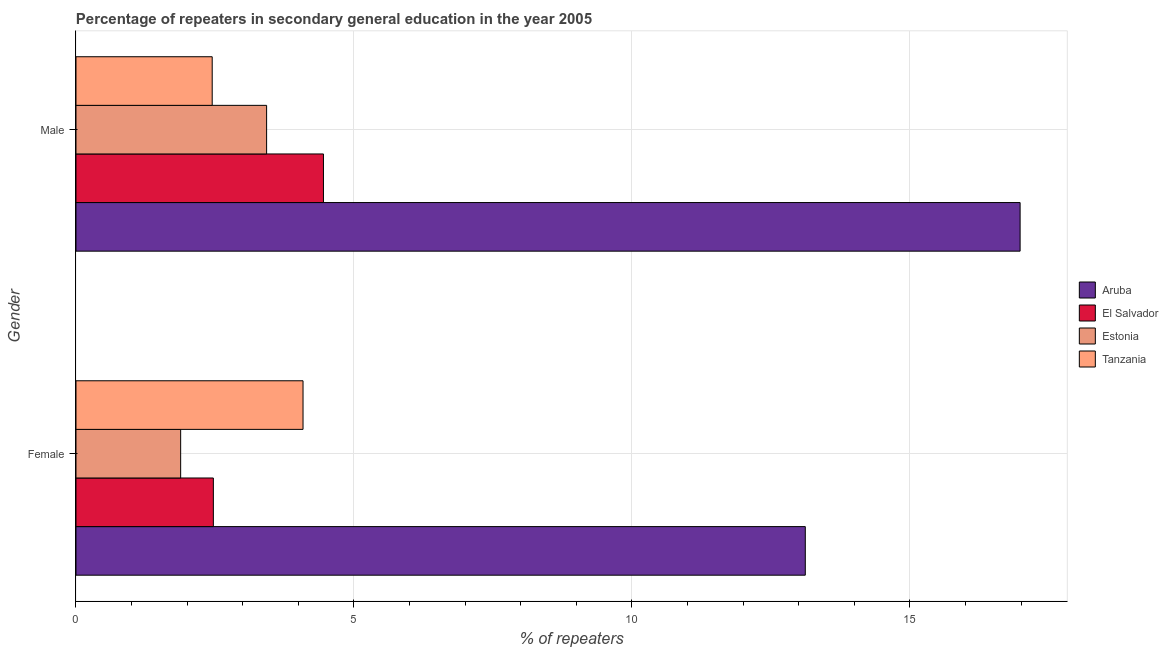How many different coloured bars are there?
Provide a succinct answer. 4. Are the number of bars on each tick of the Y-axis equal?
Ensure brevity in your answer.  Yes. How many bars are there on the 1st tick from the bottom?
Give a very brief answer. 4. What is the label of the 1st group of bars from the top?
Make the answer very short. Male. What is the percentage of male repeaters in Tanzania?
Ensure brevity in your answer.  2.45. Across all countries, what is the maximum percentage of male repeaters?
Give a very brief answer. 16.98. Across all countries, what is the minimum percentage of female repeaters?
Provide a short and direct response. 1.88. In which country was the percentage of female repeaters maximum?
Your response must be concise. Aruba. In which country was the percentage of female repeaters minimum?
Your answer should be compact. Estonia. What is the total percentage of male repeaters in the graph?
Make the answer very short. 27.31. What is the difference between the percentage of male repeaters in Tanzania and that in El Salvador?
Keep it short and to the point. -2. What is the difference between the percentage of male repeaters in Aruba and the percentage of female repeaters in Estonia?
Keep it short and to the point. 15.1. What is the average percentage of male repeaters per country?
Your answer should be very brief. 6.83. What is the difference between the percentage of male repeaters and percentage of female repeaters in Estonia?
Ensure brevity in your answer.  1.55. In how many countries, is the percentage of male repeaters greater than 6 %?
Provide a succinct answer. 1. What is the ratio of the percentage of female repeaters in Tanzania to that in El Salvador?
Ensure brevity in your answer.  1.65. Is the percentage of male repeaters in Estonia less than that in Tanzania?
Your answer should be very brief. No. In how many countries, is the percentage of female repeaters greater than the average percentage of female repeaters taken over all countries?
Make the answer very short. 1. What does the 4th bar from the top in Female represents?
Offer a terse response. Aruba. What does the 3rd bar from the bottom in Female represents?
Your response must be concise. Estonia. Are the values on the major ticks of X-axis written in scientific E-notation?
Offer a very short reply. No. Does the graph contain any zero values?
Your response must be concise. No. Does the graph contain grids?
Your answer should be very brief. Yes. What is the title of the graph?
Offer a terse response. Percentage of repeaters in secondary general education in the year 2005. What is the label or title of the X-axis?
Provide a succinct answer. % of repeaters. What is the label or title of the Y-axis?
Your answer should be compact. Gender. What is the % of repeaters of Aruba in Female?
Your answer should be compact. 13.12. What is the % of repeaters of El Salvador in Female?
Your answer should be very brief. 2.47. What is the % of repeaters in Estonia in Female?
Your answer should be compact. 1.88. What is the % of repeaters in Tanzania in Female?
Your answer should be very brief. 4.08. What is the % of repeaters of Aruba in Male?
Your answer should be compact. 16.98. What is the % of repeaters of El Salvador in Male?
Keep it short and to the point. 4.45. What is the % of repeaters in Estonia in Male?
Your response must be concise. 3.43. What is the % of repeaters in Tanzania in Male?
Your response must be concise. 2.45. Across all Gender, what is the maximum % of repeaters of Aruba?
Your response must be concise. 16.98. Across all Gender, what is the maximum % of repeaters of El Salvador?
Provide a short and direct response. 4.45. Across all Gender, what is the maximum % of repeaters in Estonia?
Ensure brevity in your answer.  3.43. Across all Gender, what is the maximum % of repeaters of Tanzania?
Your response must be concise. 4.08. Across all Gender, what is the minimum % of repeaters of Aruba?
Provide a succinct answer. 13.12. Across all Gender, what is the minimum % of repeaters in El Salvador?
Make the answer very short. 2.47. Across all Gender, what is the minimum % of repeaters in Estonia?
Keep it short and to the point. 1.88. Across all Gender, what is the minimum % of repeaters in Tanzania?
Keep it short and to the point. 2.45. What is the total % of repeaters of Aruba in the graph?
Provide a succinct answer. 30.1. What is the total % of repeaters of El Salvador in the graph?
Your answer should be compact. 6.92. What is the total % of repeaters of Estonia in the graph?
Provide a short and direct response. 5.31. What is the total % of repeaters in Tanzania in the graph?
Offer a very short reply. 6.53. What is the difference between the % of repeaters in Aruba in Female and that in Male?
Offer a terse response. -3.86. What is the difference between the % of repeaters in El Salvador in Female and that in Male?
Offer a very short reply. -1.98. What is the difference between the % of repeaters in Estonia in Female and that in Male?
Provide a short and direct response. -1.55. What is the difference between the % of repeaters of Tanzania in Female and that in Male?
Offer a terse response. 1.63. What is the difference between the % of repeaters of Aruba in Female and the % of repeaters of El Salvador in Male?
Offer a terse response. 8.67. What is the difference between the % of repeaters in Aruba in Female and the % of repeaters in Estonia in Male?
Offer a very short reply. 9.69. What is the difference between the % of repeaters in Aruba in Female and the % of repeaters in Tanzania in Male?
Provide a short and direct response. 10.67. What is the difference between the % of repeaters of El Salvador in Female and the % of repeaters of Estonia in Male?
Offer a terse response. -0.96. What is the difference between the % of repeaters of El Salvador in Female and the % of repeaters of Tanzania in Male?
Ensure brevity in your answer.  0.02. What is the difference between the % of repeaters of Estonia in Female and the % of repeaters of Tanzania in Male?
Your response must be concise. -0.57. What is the average % of repeaters of Aruba per Gender?
Your response must be concise. 15.05. What is the average % of repeaters in El Salvador per Gender?
Ensure brevity in your answer.  3.46. What is the average % of repeaters in Estonia per Gender?
Make the answer very short. 2.66. What is the average % of repeaters of Tanzania per Gender?
Your answer should be compact. 3.27. What is the difference between the % of repeaters of Aruba and % of repeaters of El Salvador in Female?
Offer a terse response. 10.65. What is the difference between the % of repeaters of Aruba and % of repeaters of Estonia in Female?
Provide a succinct answer. 11.23. What is the difference between the % of repeaters of Aruba and % of repeaters of Tanzania in Female?
Provide a succinct answer. 9.03. What is the difference between the % of repeaters of El Salvador and % of repeaters of Estonia in Female?
Offer a terse response. 0.59. What is the difference between the % of repeaters of El Salvador and % of repeaters of Tanzania in Female?
Provide a succinct answer. -1.61. What is the difference between the % of repeaters of Estonia and % of repeaters of Tanzania in Female?
Provide a succinct answer. -2.2. What is the difference between the % of repeaters of Aruba and % of repeaters of El Salvador in Male?
Offer a very short reply. 12.53. What is the difference between the % of repeaters in Aruba and % of repeaters in Estonia in Male?
Your answer should be compact. 13.55. What is the difference between the % of repeaters of Aruba and % of repeaters of Tanzania in Male?
Offer a terse response. 14.53. What is the difference between the % of repeaters of El Salvador and % of repeaters of Estonia in Male?
Offer a terse response. 1.02. What is the difference between the % of repeaters in El Salvador and % of repeaters in Tanzania in Male?
Give a very brief answer. 2. What is the difference between the % of repeaters in Estonia and % of repeaters in Tanzania in Male?
Ensure brevity in your answer.  0.98. What is the ratio of the % of repeaters of Aruba in Female to that in Male?
Your answer should be compact. 0.77. What is the ratio of the % of repeaters of El Salvador in Female to that in Male?
Ensure brevity in your answer.  0.56. What is the ratio of the % of repeaters in Estonia in Female to that in Male?
Your response must be concise. 0.55. What is the ratio of the % of repeaters of Tanzania in Female to that in Male?
Ensure brevity in your answer.  1.67. What is the difference between the highest and the second highest % of repeaters of Aruba?
Provide a short and direct response. 3.86. What is the difference between the highest and the second highest % of repeaters of El Salvador?
Give a very brief answer. 1.98. What is the difference between the highest and the second highest % of repeaters in Estonia?
Make the answer very short. 1.55. What is the difference between the highest and the second highest % of repeaters in Tanzania?
Keep it short and to the point. 1.63. What is the difference between the highest and the lowest % of repeaters in Aruba?
Your answer should be very brief. 3.86. What is the difference between the highest and the lowest % of repeaters of El Salvador?
Offer a terse response. 1.98. What is the difference between the highest and the lowest % of repeaters in Estonia?
Give a very brief answer. 1.55. What is the difference between the highest and the lowest % of repeaters of Tanzania?
Your response must be concise. 1.63. 